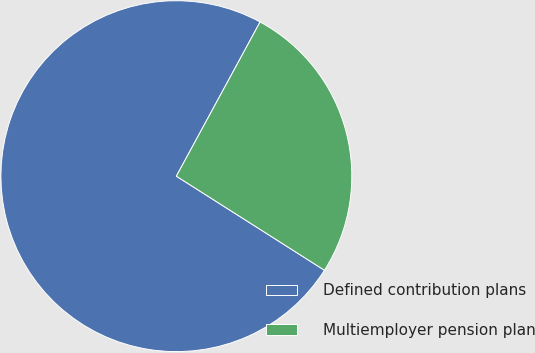Convert chart to OTSL. <chart><loc_0><loc_0><loc_500><loc_500><pie_chart><fcel>Defined contribution plans<fcel>Multiemployer pension plan<nl><fcel>73.91%<fcel>26.09%<nl></chart> 